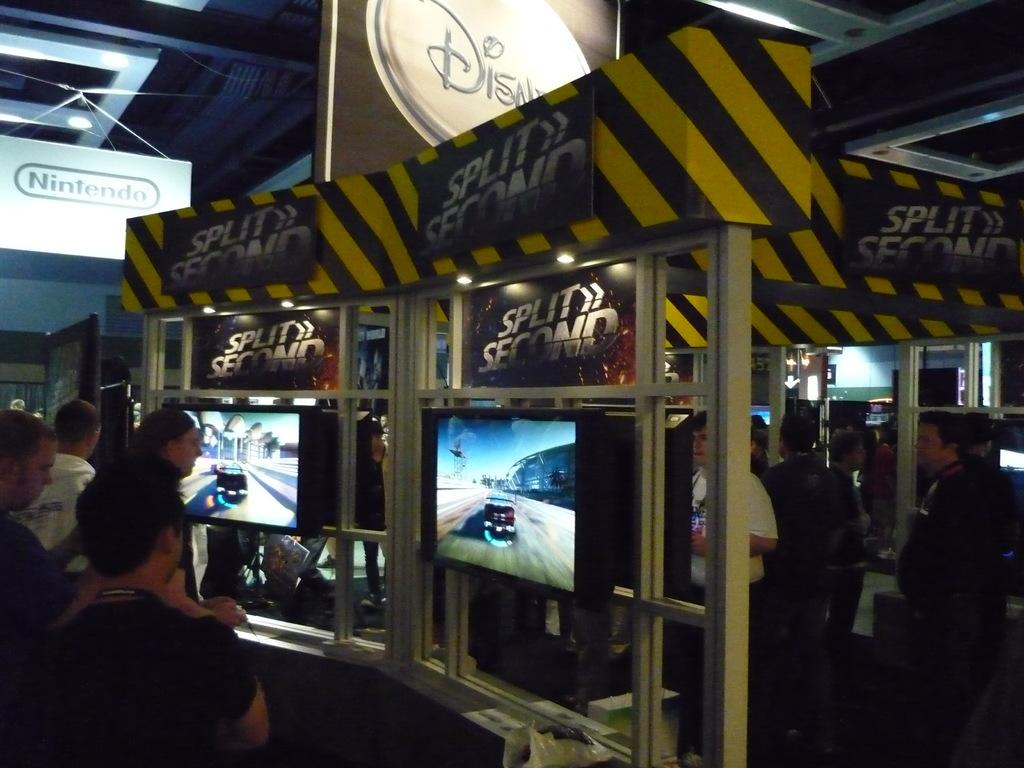How many persons are in the image? There are persons standing in the image. What are the persons looking at in the image? The persons are looking at television screens in front of them. What can be seen in the background of the image? There is a ceiling visible in the background of the image, and boards are attached to the ceiling. What type of cabbage is being discovered in the image? There is no cabbage present in the image, and no discovery is taking place. 